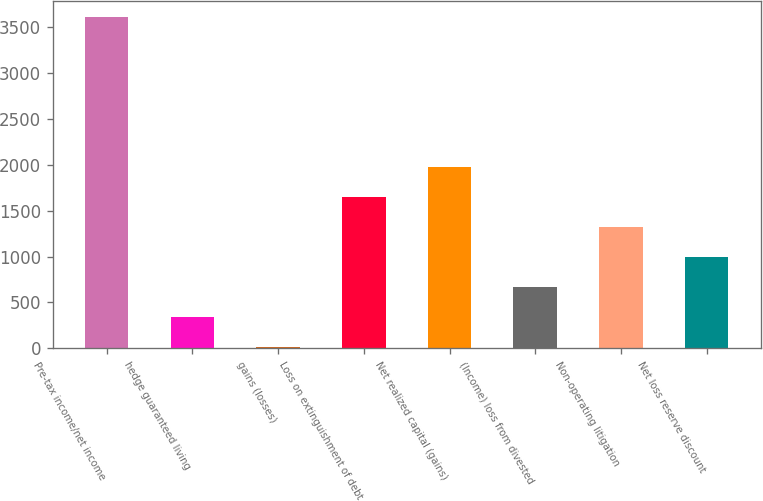Convert chart to OTSL. <chart><loc_0><loc_0><loc_500><loc_500><bar_chart><fcel>Pre-tax income/net income<fcel>hedge guaranteed living<fcel>gains (losses)<fcel>Loss on extinguishment of debt<fcel>Net realized capital (gains)<fcel>(Income) loss from divested<fcel>Non-operating litigation<fcel>Net loss reserve discount<nl><fcel>3607.6<fcel>341.6<fcel>15<fcel>1648<fcel>1974.6<fcel>668.2<fcel>1321.4<fcel>994.8<nl></chart> 